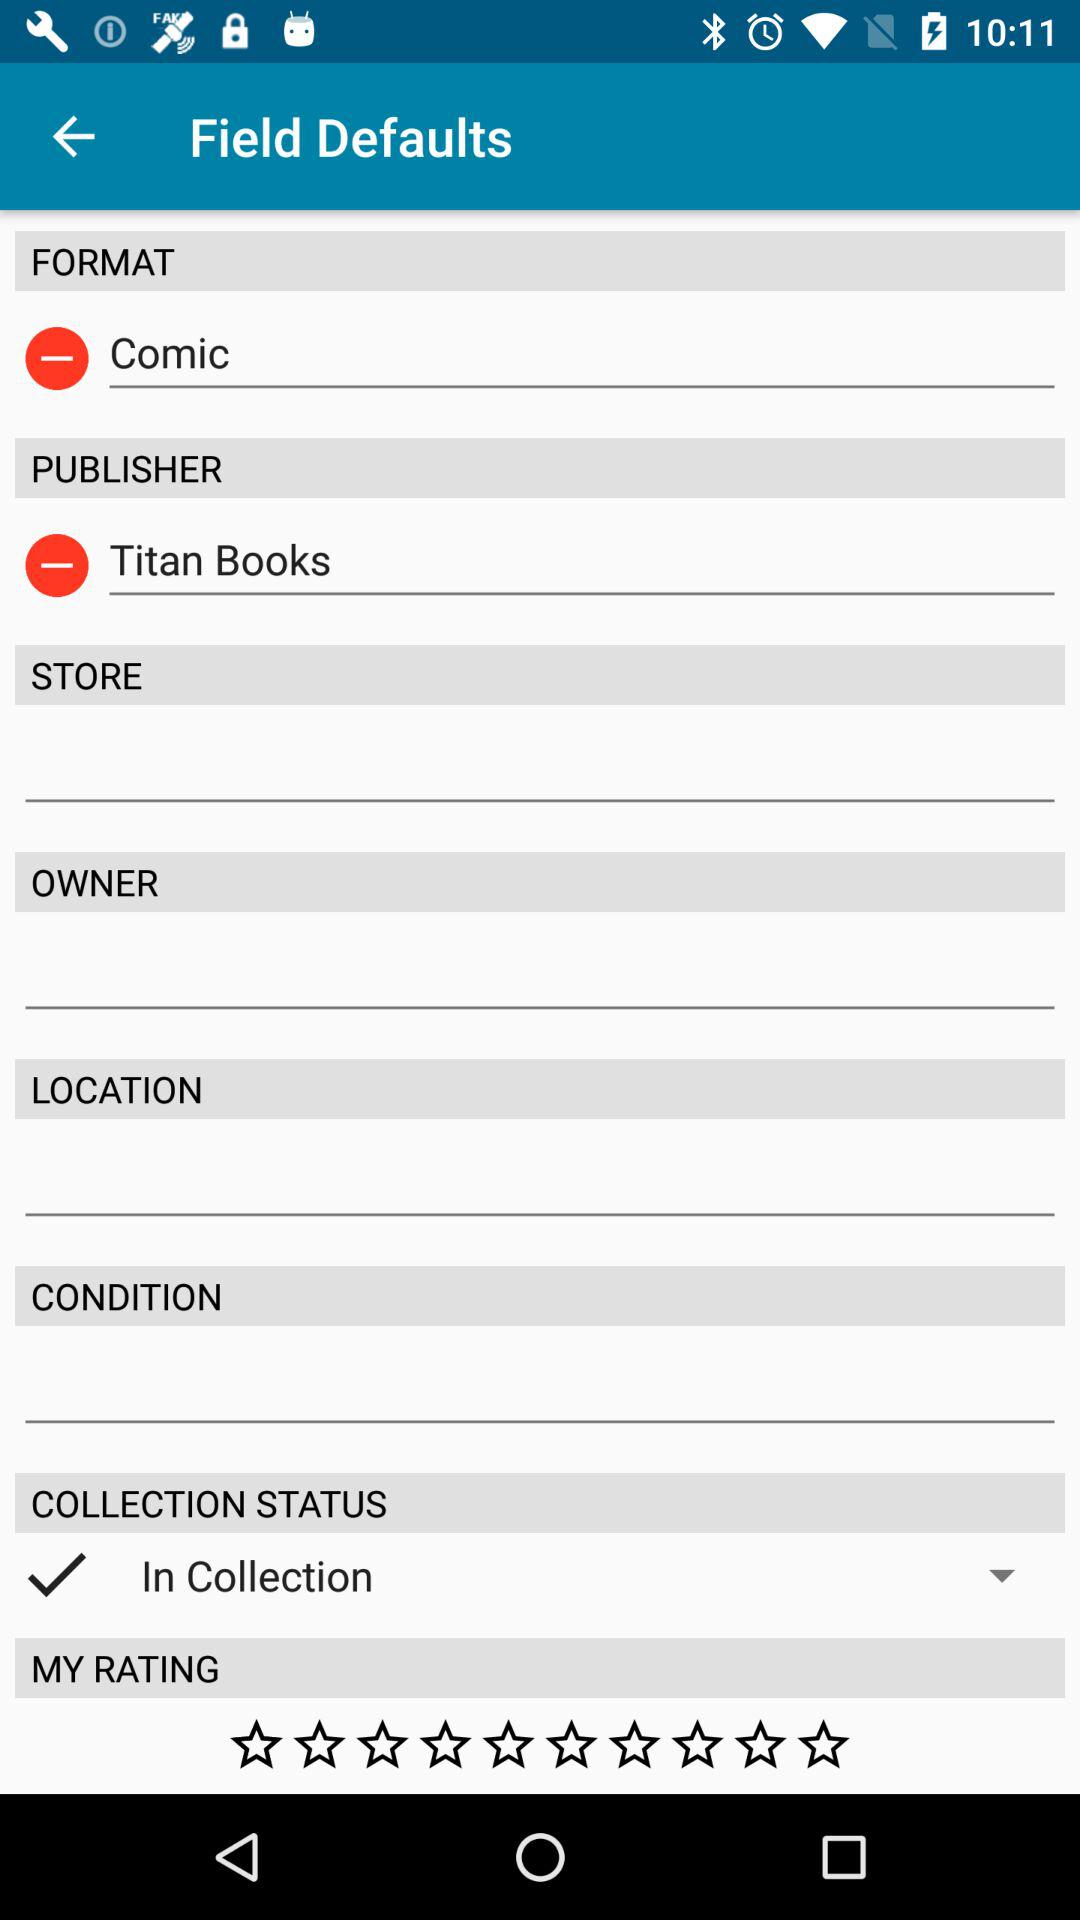What is the format? The format is "Comic". 